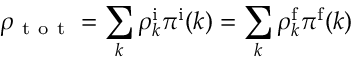<formula> <loc_0><loc_0><loc_500><loc_500>\rho _ { t o t } = \sum _ { k } \rho _ { k } ^ { \mathrm i } \pi ^ { \mathrm i } ( k ) = \sum _ { k } \rho _ { k } ^ { \mathrm f } \pi ^ { \mathrm f } ( k )</formula> 